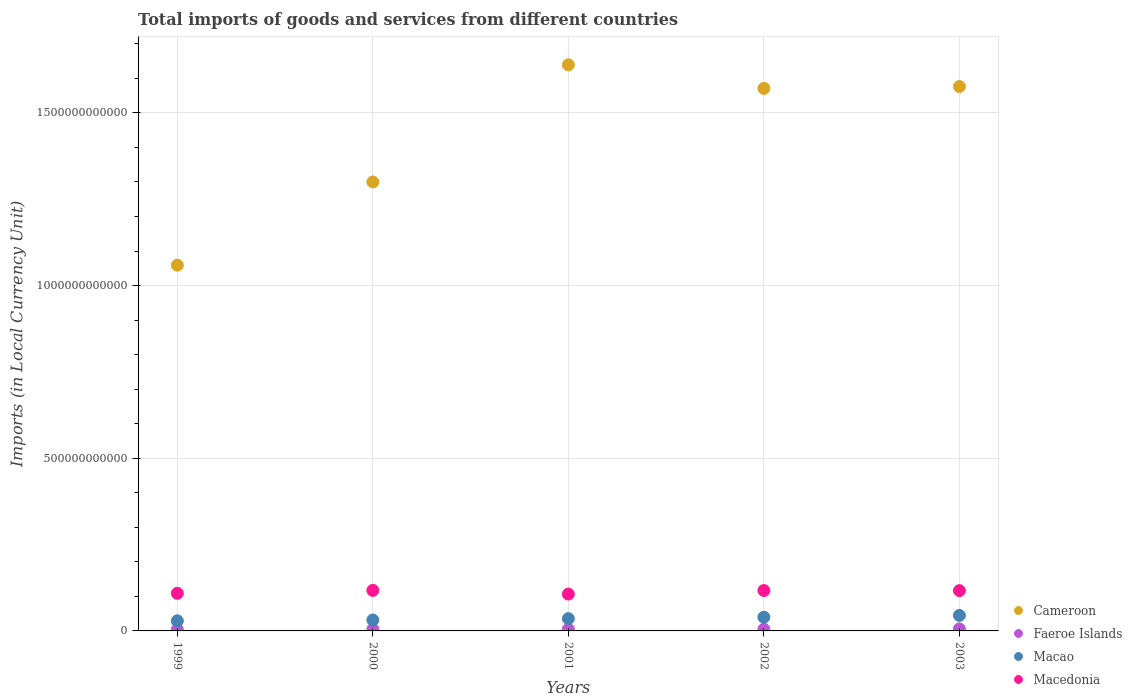How many different coloured dotlines are there?
Your answer should be very brief. 4. Is the number of dotlines equal to the number of legend labels?
Give a very brief answer. Yes. What is the Amount of goods and services imports in Macedonia in 2000?
Your answer should be very brief. 1.17e+11. Across all years, what is the maximum Amount of goods and services imports in Faeroe Islands?
Keep it short and to the point. 5.73e+09. Across all years, what is the minimum Amount of goods and services imports in Faeroe Islands?
Offer a very short reply. 3.90e+09. In which year was the Amount of goods and services imports in Faeroe Islands minimum?
Keep it short and to the point. 1999. What is the total Amount of goods and services imports in Macao in the graph?
Offer a terse response. 1.81e+11. What is the difference between the Amount of goods and services imports in Macao in 2000 and that in 2003?
Your response must be concise. -1.33e+1. What is the difference between the Amount of goods and services imports in Macedonia in 2003 and the Amount of goods and services imports in Macao in 2000?
Give a very brief answer. 8.50e+1. What is the average Amount of goods and services imports in Faeroe Islands per year?
Your response must be concise. 4.85e+09. In the year 2003, what is the difference between the Amount of goods and services imports in Macao and Amount of goods and services imports in Cameroon?
Offer a terse response. -1.53e+12. In how many years, is the Amount of goods and services imports in Cameroon greater than 1300000000000 LCU?
Ensure brevity in your answer.  4. What is the ratio of the Amount of goods and services imports in Faeroe Islands in 1999 to that in 2003?
Your answer should be compact. 0.68. What is the difference between the highest and the second highest Amount of goods and services imports in Macao?
Your response must be concise. 5.34e+09. What is the difference between the highest and the lowest Amount of goods and services imports in Cameroon?
Keep it short and to the point. 5.80e+11. In how many years, is the Amount of goods and services imports in Faeroe Islands greater than the average Amount of goods and services imports in Faeroe Islands taken over all years?
Your answer should be compact. 3. Is the Amount of goods and services imports in Cameroon strictly greater than the Amount of goods and services imports in Faeroe Islands over the years?
Ensure brevity in your answer.  Yes. Is the Amount of goods and services imports in Cameroon strictly less than the Amount of goods and services imports in Macao over the years?
Give a very brief answer. No. What is the difference between two consecutive major ticks on the Y-axis?
Ensure brevity in your answer.  5.00e+11. Are the values on the major ticks of Y-axis written in scientific E-notation?
Provide a succinct answer. No. Does the graph contain any zero values?
Give a very brief answer. No. What is the title of the graph?
Your answer should be very brief. Total imports of goods and services from different countries. Does "Tuvalu" appear as one of the legend labels in the graph?
Offer a terse response. No. What is the label or title of the X-axis?
Make the answer very short. Years. What is the label or title of the Y-axis?
Make the answer very short. Imports (in Local Currency Unit). What is the Imports (in Local Currency Unit) in Cameroon in 1999?
Keep it short and to the point. 1.06e+12. What is the Imports (in Local Currency Unit) of Faeroe Islands in 1999?
Provide a succinct answer. 3.90e+09. What is the Imports (in Local Currency Unit) of Macao in 1999?
Ensure brevity in your answer.  2.92e+1. What is the Imports (in Local Currency Unit) of Macedonia in 1999?
Offer a terse response. 1.09e+11. What is the Imports (in Local Currency Unit) in Cameroon in 2000?
Give a very brief answer. 1.30e+12. What is the Imports (in Local Currency Unit) of Faeroe Islands in 2000?
Ensure brevity in your answer.  4.94e+09. What is the Imports (in Local Currency Unit) in Macao in 2000?
Your answer should be very brief. 3.17e+1. What is the Imports (in Local Currency Unit) of Macedonia in 2000?
Provide a succinct answer. 1.17e+11. What is the Imports (in Local Currency Unit) in Cameroon in 2001?
Your answer should be compact. 1.64e+12. What is the Imports (in Local Currency Unit) of Faeroe Islands in 2001?
Provide a succinct answer. 4.86e+09. What is the Imports (in Local Currency Unit) in Macao in 2001?
Provide a succinct answer. 3.56e+1. What is the Imports (in Local Currency Unit) in Macedonia in 2001?
Ensure brevity in your answer.  1.07e+11. What is the Imports (in Local Currency Unit) of Cameroon in 2002?
Offer a very short reply. 1.57e+12. What is the Imports (in Local Currency Unit) in Faeroe Islands in 2002?
Your answer should be very brief. 4.82e+09. What is the Imports (in Local Currency Unit) of Macao in 2002?
Give a very brief answer. 3.96e+1. What is the Imports (in Local Currency Unit) of Macedonia in 2002?
Your answer should be very brief. 1.17e+11. What is the Imports (in Local Currency Unit) in Cameroon in 2003?
Your response must be concise. 1.58e+12. What is the Imports (in Local Currency Unit) in Faeroe Islands in 2003?
Offer a very short reply. 5.73e+09. What is the Imports (in Local Currency Unit) in Macao in 2003?
Provide a succinct answer. 4.49e+1. What is the Imports (in Local Currency Unit) in Macedonia in 2003?
Your answer should be compact. 1.17e+11. Across all years, what is the maximum Imports (in Local Currency Unit) in Cameroon?
Your answer should be very brief. 1.64e+12. Across all years, what is the maximum Imports (in Local Currency Unit) in Faeroe Islands?
Ensure brevity in your answer.  5.73e+09. Across all years, what is the maximum Imports (in Local Currency Unit) in Macao?
Ensure brevity in your answer.  4.49e+1. Across all years, what is the maximum Imports (in Local Currency Unit) of Macedonia?
Keep it short and to the point. 1.17e+11. Across all years, what is the minimum Imports (in Local Currency Unit) in Cameroon?
Provide a short and direct response. 1.06e+12. Across all years, what is the minimum Imports (in Local Currency Unit) in Faeroe Islands?
Your answer should be very brief. 3.90e+09. Across all years, what is the minimum Imports (in Local Currency Unit) in Macao?
Offer a very short reply. 2.92e+1. Across all years, what is the minimum Imports (in Local Currency Unit) of Macedonia?
Give a very brief answer. 1.07e+11. What is the total Imports (in Local Currency Unit) in Cameroon in the graph?
Your answer should be compact. 7.15e+12. What is the total Imports (in Local Currency Unit) of Faeroe Islands in the graph?
Your answer should be compact. 2.43e+1. What is the total Imports (in Local Currency Unit) of Macao in the graph?
Keep it short and to the point. 1.81e+11. What is the total Imports (in Local Currency Unit) of Macedonia in the graph?
Keep it short and to the point. 5.67e+11. What is the difference between the Imports (in Local Currency Unit) of Cameroon in 1999 and that in 2000?
Your answer should be very brief. -2.41e+11. What is the difference between the Imports (in Local Currency Unit) in Faeroe Islands in 1999 and that in 2000?
Provide a succinct answer. -1.04e+09. What is the difference between the Imports (in Local Currency Unit) in Macao in 1999 and that in 2000?
Your answer should be very brief. -2.44e+09. What is the difference between the Imports (in Local Currency Unit) of Macedonia in 1999 and that in 2000?
Your response must be concise. -8.39e+09. What is the difference between the Imports (in Local Currency Unit) in Cameroon in 1999 and that in 2001?
Give a very brief answer. -5.80e+11. What is the difference between the Imports (in Local Currency Unit) of Faeroe Islands in 1999 and that in 2001?
Provide a succinct answer. -9.61e+08. What is the difference between the Imports (in Local Currency Unit) of Macao in 1999 and that in 2001?
Offer a terse response. -6.38e+09. What is the difference between the Imports (in Local Currency Unit) in Macedonia in 1999 and that in 2001?
Ensure brevity in your answer.  2.30e+09. What is the difference between the Imports (in Local Currency Unit) of Cameroon in 1999 and that in 2002?
Ensure brevity in your answer.  -5.12e+11. What is the difference between the Imports (in Local Currency Unit) of Faeroe Islands in 1999 and that in 2002?
Offer a very short reply. -9.17e+08. What is the difference between the Imports (in Local Currency Unit) of Macao in 1999 and that in 2002?
Make the answer very short. -1.04e+1. What is the difference between the Imports (in Local Currency Unit) of Macedonia in 1999 and that in 2002?
Provide a short and direct response. -7.96e+09. What is the difference between the Imports (in Local Currency Unit) of Cameroon in 1999 and that in 2003?
Make the answer very short. -5.17e+11. What is the difference between the Imports (in Local Currency Unit) in Faeroe Islands in 1999 and that in 2003?
Your answer should be compact. -1.82e+09. What is the difference between the Imports (in Local Currency Unit) of Macao in 1999 and that in 2003?
Your response must be concise. -1.57e+1. What is the difference between the Imports (in Local Currency Unit) of Macedonia in 1999 and that in 2003?
Your answer should be very brief. -7.64e+09. What is the difference between the Imports (in Local Currency Unit) of Cameroon in 2000 and that in 2001?
Make the answer very short. -3.39e+11. What is the difference between the Imports (in Local Currency Unit) in Faeroe Islands in 2000 and that in 2001?
Provide a succinct answer. 7.50e+07. What is the difference between the Imports (in Local Currency Unit) in Macao in 2000 and that in 2001?
Your response must be concise. -3.94e+09. What is the difference between the Imports (in Local Currency Unit) in Macedonia in 2000 and that in 2001?
Make the answer very short. 1.07e+1. What is the difference between the Imports (in Local Currency Unit) in Cameroon in 2000 and that in 2002?
Your answer should be compact. -2.71e+11. What is the difference between the Imports (in Local Currency Unit) of Faeroe Islands in 2000 and that in 2002?
Your response must be concise. 1.19e+08. What is the difference between the Imports (in Local Currency Unit) of Macao in 2000 and that in 2002?
Your answer should be very brief. -7.93e+09. What is the difference between the Imports (in Local Currency Unit) of Macedonia in 2000 and that in 2002?
Give a very brief answer. 4.31e+08. What is the difference between the Imports (in Local Currency Unit) of Cameroon in 2000 and that in 2003?
Your answer should be very brief. -2.76e+11. What is the difference between the Imports (in Local Currency Unit) of Faeroe Islands in 2000 and that in 2003?
Your answer should be compact. -7.89e+08. What is the difference between the Imports (in Local Currency Unit) of Macao in 2000 and that in 2003?
Provide a succinct answer. -1.33e+1. What is the difference between the Imports (in Local Currency Unit) of Macedonia in 2000 and that in 2003?
Your response must be concise. 7.46e+08. What is the difference between the Imports (in Local Currency Unit) in Cameroon in 2001 and that in 2002?
Offer a very short reply. 6.83e+1. What is the difference between the Imports (in Local Currency Unit) in Faeroe Islands in 2001 and that in 2002?
Offer a terse response. 4.40e+07. What is the difference between the Imports (in Local Currency Unit) in Macao in 2001 and that in 2002?
Your response must be concise. -3.99e+09. What is the difference between the Imports (in Local Currency Unit) of Macedonia in 2001 and that in 2002?
Offer a terse response. -1.03e+1. What is the difference between the Imports (in Local Currency Unit) in Cameroon in 2001 and that in 2003?
Ensure brevity in your answer.  6.29e+1. What is the difference between the Imports (in Local Currency Unit) of Faeroe Islands in 2001 and that in 2003?
Provide a succinct answer. -8.64e+08. What is the difference between the Imports (in Local Currency Unit) in Macao in 2001 and that in 2003?
Provide a short and direct response. -9.33e+09. What is the difference between the Imports (in Local Currency Unit) of Macedonia in 2001 and that in 2003?
Your answer should be compact. -9.94e+09. What is the difference between the Imports (in Local Currency Unit) in Cameroon in 2002 and that in 2003?
Your response must be concise. -5.41e+09. What is the difference between the Imports (in Local Currency Unit) of Faeroe Islands in 2002 and that in 2003?
Ensure brevity in your answer.  -9.08e+08. What is the difference between the Imports (in Local Currency Unit) in Macao in 2002 and that in 2003?
Ensure brevity in your answer.  -5.34e+09. What is the difference between the Imports (in Local Currency Unit) of Macedonia in 2002 and that in 2003?
Keep it short and to the point. 3.15e+08. What is the difference between the Imports (in Local Currency Unit) of Cameroon in 1999 and the Imports (in Local Currency Unit) of Faeroe Islands in 2000?
Provide a short and direct response. 1.05e+12. What is the difference between the Imports (in Local Currency Unit) in Cameroon in 1999 and the Imports (in Local Currency Unit) in Macao in 2000?
Provide a short and direct response. 1.03e+12. What is the difference between the Imports (in Local Currency Unit) of Cameroon in 1999 and the Imports (in Local Currency Unit) of Macedonia in 2000?
Provide a succinct answer. 9.42e+11. What is the difference between the Imports (in Local Currency Unit) of Faeroe Islands in 1999 and the Imports (in Local Currency Unit) of Macao in 2000?
Provide a short and direct response. -2.77e+1. What is the difference between the Imports (in Local Currency Unit) in Faeroe Islands in 1999 and the Imports (in Local Currency Unit) in Macedonia in 2000?
Give a very brief answer. -1.13e+11. What is the difference between the Imports (in Local Currency Unit) in Macao in 1999 and the Imports (in Local Currency Unit) in Macedonia in 2000?
Offer a terse response. -8.82e+1. What is the difference between the Imports (in Local Currency Unit) in Cameroon in 1999 and the Imports (in Local Currency Unit) in Faeroe Islands in 2001?
Your answer should be very brief. 1.05e+12. What is the difference between the Imports (in Local Currency Unit) in Cameroon in 1999 and the Imports (in Local Currency Unit) in Macao in 2001?
Offer a very short reply. 1.02e+12. What is the difference between the Imports (in Local Currency Unit) of Cameroon in 1999 and the Imports (in Local Currency Unit) of Macedonia in 2001?
Offer a very short reply. 9.52e+11. What is the difference between the Imports (in Local Currency Unit) in Faeroe Islands in 1999 and the Imports (in Local Currency Unit) in Macao in 2001?
Offer a very short reply. -3.17e+1. What is the difference between the Imports (in Local Currency Unit) in Faeroe Islands in 1999 and the Imports (in Local Currency Unit) in Macedonia in 2001?
Your answer should be very brief. -1.03e+11. What is the difference between the Imports (in Local Currency Unit) of Macao in 1999 and the Imports (in Local Currency Unit) of Macedonia in 2001?
Your answer should be compact. -7.75e+1. What is the difference between the Imports (in Local Currency Unit) in Cameroon in 1999 and the Imports (in Local Currency Unit) in Faeroe Islands in 2002?
Keep it short and to the point. 1.05e+12. What is the difference between the Imports (in Local Currency Unit) in Cameroon in 1999 and the Imports (in Local Currency Unit) in Macao in 2002?
Your answer should be very brief. 1.02e+12. What is the difference between the Imports (in Local Currency Unit) of Cameroon in 1999 and the Imports (in Local Currency Unit) of Macedonia in 2002?
Your answer should be compact. 9.42e+11. What is the difference between the Imports (in Local Currency Unit) of Faeroe Islands in 1999 and the Imports (in Local Currency Unit) of Macao in 2002?
Your response must be concise. -3.57e+1. What is the difference between the Imports (in Local Currency Unit) in Faeroe Islands in 1999 and the Imports (in Local Currency Unit) in Macedonia in 2002?
Give a very brief answer. -1.13e+11. What is the difference between the Imports (in Local Currency Unit) of Macao in 1999 and the Imports (in Local Currency Unit) of Macedonia in 2002?
Provide a short and direct response. -8.78e+1. What is the difference between the Imports (in Local Currency Unit) in Cameroon in 1999 and the Imports (in Local Currency Unit) in Faeroe Islands in 2003?
Make the answer very short. 1.05e+12. What is the difference between the Imports (in Local Currency Unit) in Cameroon in 1999 and the Imports (in Local Currency Unit) in Macao in 2003?
Provide a short and direct response. 1.01e+12. What is the difference between the Imports (in Local Currency Unit) of Cameroon in 1999 and the Imports (in Local Currency Unit) of Macedonia in 2003?
Give a very brief answer. 9.42e+11. What is the difference between the Imports (in Local Currency Unit) of Faeroe Islands in 1999 and the Imports (in Local Currency Unit) of Macao in 2003?
Offer a terse response. -4.10e+1. What is the difference between the Imports (in Local Currency Unit) in Faeroe Islands in 1999 and the Imports (in Local Currency Unit) in Macedonia in 2003?
Your answer should be compact. -1.13e+11. What is the difference between the Imports (in Local Currency Unit) in Macao in 1999 and the Imports (in Local Currency Unit) in Macedonia in 2003?
Keep it short and to the point. -8.74e+1. What is the difference between the Imports (in Local Currency Unit) in Cameroon in 2000 and the Imports (in Local Currency Unit) in Faeroe Islands in 2001?
Give a very brief answer. 1.30e+12. What is the difference between the Imports (in Local Currency Unit) in Cameroon in 2000 and the Imports (in Local Currency Unit) in Macao in 2001?
Your answer should be very brief. 1.26e+12. What is the difference between the Imports (in Local Currency Unit) of Cameroon in 2000 and the Imports (in Local Currency Unit) of Macedonia in 2001?
Ensure brevity in your answer.  1.19e+12. What is the difference between the Imports (in Local Currency Unit) in Faeroe Islands in 2000 and the Imports (in Local Currency Unit) in Macao in 2001?
Provide a succinct answer. -3.07e+1. What is the difference between the Imports (in Local Currency Unit) of Faeroe Islands in 2000 and the Imports (in Local Currency Unit) of Macedonia in 2001?
Provide a short and direct response. -1.02e+11. What is the difference between the Imports (in Local Currency Unit) of Macao in 2000 and the Imports (in Local Currency Unit) of Macedonia in 2001?
Provide a short and direct response. -7.51e+1. What is the difference between the Imports (in Local Currency Unit) in Cameroon in 2000 and the Imports (in Local Currency Unit) in Faeroe Islands in 2002?
Provide a short and direct response. 1.30e+12. What is the difference between the Imports (in Local Currency Unit) of Cameroon in 2000 and the Imports (in Local Currency Unit) of Macao in 2002?
Offer a terse response. 1.26e+12. What is the difference between the Imports (in Local Currency Unit) of Cameroon in 2000 and the Imports (in Local Currency Unit) of Macedonia in 2002?
Your response must be concise. 1.18e+12. What is the difference between the Imports (in Local Currency Unit) of Faeroe Islands in 2000 and the Imports (in Local Currency Unit) of Macao in 2002?
Make the answer very short. -3.46e+1. What is the difference between the Imports (in Local Currency Unit) in Faeroe Islands in 2000 and the Imports (in Local Currency Unit) in Macedonia in 2002?
Provide a short and direct response. -1.12e+11. What is the difference between the Imports (in Local Currency Unit) in Macao in 2000 and the Imports (in Local Currency Unit) in Macedonia in 2002?
Offer a terse response. -8.53e+1. What is the difference between the Imports (in Local Currency Unit) of Cameroon in 2000 and the Imports (in Local Currency Unit) of Faeroe Islands in 2003?
Keep it short and to the point. 1.29e+12. What is the difference between the Imports (in Local Currency Unit) of Cameroon in 2000 and the Imports (in Local Currency Unit) of Macao in 2003?
Provide a short and direct response. 1.26e+12. What is the difference between the Imports (in Local Currency Unit) in Cameroon in 2000 and the Imports (in Local Currency Unit) in Macedonia in 2003?
Make the answer very short. 1.18e+12. What is the difference between the Imports (in Local Currency Unit) in Faeroe Islands in 2000 and the Imports (in Local Currency Unit) in Macao in 2003?
Make the answer very short. -4.00e+1. What is the difference between the Imports (in Local Currency Unit) in Faeroe Islands in 2000 and the Imports (in Local Currency Unit) in Macedonia in 2003?
Provide a succinct answer. -1.12e+11. What is the difference between the Imports (in Local Currency Unit) in Macao in 2000 and the Imports (in Local Currency Unit) in Macedonia in 2003?
Make the answer very short. -8.50e+1. What is the difference between the Imports (in Local Currency Unit) in Cameroon in 2001 and the Imports (in Local Currency Unit) in Faeroe Islands in 2002?
Your answer should be very brief. 1.63e+12. What is the difference between the Imports (in Local Currency Unit) in Cameroon in 2001 and the Imports (in Local Currency Unit) in Macao in 2002?
Your answer should be very brief. 1.60e+12. What is the difference between the Imports (in Local Currency Unit) in Cameroon in 2001 and the Imports (in Local Currency Unit) in Macedonia in 2002?
Your answer should be very brief. 1.52e+12. What is the difference between the Imports (in Local Currency Unit) in Faeroe Islands in 2001 and the Imports (in Local Currency Unit) in Macao in 2002?
Your answer should be very brief. -3.47e+1. What is the difference between the Imports (in Local Currency Unit) of Faeroe Islands in 2001 and the Imports (in Local Currency Unit) of Macedonia in 2002?
Provide a succinct answer. -1.12e+11. What is the difference between the Imports (in Local Currency Unit) in Macao in 2001 and the Imports (in Local Currency Unit) in Macedonia in 2002?
Provide a short and direct response. -8.14e+1. What is the difference between the Imports (in Local Currency Unit) in Cameroon in 2001 and the Imports (in Local Currency Unit) in Faeroe Islands in 2003?
Ensure brevity in your answer.  1.63e+12. What is the difference between the Imports (in Local Currency Unit) of Cameroon in 2001 and the Imports (in Local Currency Unit) of Macao in 2003?
Provide a succinct answer. 1.59e+12. What is the difference between the Imports (in Local Currency Unit) in Cameroon in 2001 and the Imports (in Local Currency Unit) in Macedonia in 2003?
Make the answer very short. 1.52e+12. What is the difference between the Imports (in Local Currency Unit) of Faeroe Islands in 2001 and the Imports (in Local Currency Unit) of Macao in 2003?
Offer a terse response. -4.01e+1. What is the difference between the Imports (in Local Currency Unit) in Faeroe Islands in 2001 and the Imports (in Local Currency Unit) in Macedonia in 2003?
Offer a very short reply. -1.12e+11. What is the difference between the Imports (in Local Currency Unit) of Macao in 2001 and the Imports (in Local Currency Unit) of Macedonia in 2003?
Give a very brief answer. -8.11e+1. What is the difference between the Imports (in Local Currency Unit) in Cameroon in 2002 and the Imports (in Local Currency Unit) in Faeroe Islands in 2003?
Offer a terse response. 1.57e+12. What is the difference between the Imports (in Local Currency Unit) of Cameroon in 2002 and the Imports (in Local Currency Unit) of Macao in 2003?
Your response must be concise. 1.53e+12. What is the difference between the Imports (in Local Currency Unit) in Cameroon in 2002 and the Imports (in Local Currency Unit) in Macedonia in 2003?
Ensure brevity in your answer.  1.45e+12. What is the difference between the Imports (in Local Currency Unit) in Faeroe Islands in 2002 and the Imports (in Local Currency Unit) in Macao in 2003?
Keep it short and to the point. -4.01e+1. What is the difference between the Imports (in Local Currency Unit) of Faeroe Islands in 2002 and the Imports (in Local Currency Unit) of Macedonia in 2003?
Provide a succinct answer. -1.12e+11. What is the difference between the Imports (in Local Currency Unit) of Macao in 2002 and the Imports (in Local Currency Unit) of Macedonia in 2003?
Your answer should be compact. -7.71e+1. What is the average Imports (in Local Currency Unit) in Cameroon per year?
Your answer should be very brief. 1.43e+12. What is the average Imports (in Local Currency Unit) in Faeroe Islands per year?
Offer a very short reply. 4.85e+09. What is the average Imports (in Local Currency Unit) of Macao per year?
Your answer should be very brief. 3.62e+1. What is the average Imports (in Local Currency Unit) of Macedonia per year?
Keep it short and to the point. 1.13e+11. In the year 1999, what is the difference between the Imports (in Local Currency Unit) in Cameroon and Imports (in Local Currency Unit) in Faeroe Islands?
Give a very brief answer. 1.06e+12. In the year 1999, what is the difference between the Imports (in Local Currency Unit) in Cameroon and Imports (in Local Currency Unit) in Macao?
Your answer should be very brief. 1.03e+12. In the year 1999, what is the difference between the Imports (in Local Currency Unit) in Cameroon and Imports (in Local Currency Unit) in Macedonia?
Provide a short and direct response. 9.50e+11. In the year 1999, what is the difference between the Imports (in Local Currency Unit) in Faeroe Islands and Imports (in Local Currency Unit) in Macao?
Your answer should be very brief. -2.53e+1. In the year 1999, what is the difference between the Imports (in Local Currency Unit) of Faeroe Islands and Imports (in Local Currency Unit) of Macedonia?
Your answer should be compact. -1.05e+11. In the year 1999, what is the difference between the Imports (in Local Currency Unit) of Macao and Imports (in Local Currency Unit) of Macedonia?
Make the answer very short. -7.98e+1. In the year 2000, what is the difference between the Imports (in Local Currency Unit) in Cameroon and Imports (in Local Currency Unit) in Faeroe Islands?
Offer a terse response. 1.30e+12. In the year 2000, what is the difference between the Imports (in Local Currency Unit) in Cameroon and Imports (in Local Currency Unit) in Macao?
Make the answer very short. 1.27e+12. In the year 2000, what is the difference between the Imports (in Local Currency Unit) in Cameroon and Imports (in Local Currency Unit) in Macedonia?
Make the answer very short. 1.18e+12. In the year 2000, what is the difference between the Imports (in Local Currency Unit) of Faeroe Islands and Imports (in Local Currency Unit) of Macao?
Offer a terse response. -2.67e+1. In the year 2000, what is the difference between the Imports (in Local Currency Unit) in Faeroe Islands and Imports (in Local Currency Unit) in Macedonia?
Your response must be concise. -1.12e+11. In the year 2000, what is the difference between the Imports (in Local Currency Unit) of Macao and Imports (in Local Currency Unit) of Macedonia?
Your response must be concise. -8.57e+1. In the year 2001, what is the difference between the Imports (in Local Currency Unit) of Cameroon and Imports (in Local Currency Unit) of Faeroe Islands?
Ensure brevity in your answer.  1.63e+12. In the year 2001, what is the difference between the Imports (in Local Currency Unit) of Cameroon and Imports (in Local Currency Unit) of Macao?
Ensure brevity in your answer.  1.60e+12. In the year 2001, what is the difference between the Imports (in Local Currency Unit) in Cameroon and Imports (in Local Currency Unit) in Macedonia?
Offer a terse response. 1.53e+12. In the year 2001, what is the difference between the Imports (in Local Currency Unit) in Faeroe Islands and Imports (in Local Currency Unit) in Macao?
Keep it short and to the point. -3.07e+1. In the year 2001, what is the difference between the Imports (in Local Currency Unit) in Faeroe Islands and Imports (in Local Currency Unit) in Macedonia?
Offer a very short reply. -1.02e+11. In the year 2001, what is the difference between the Imports (in Local Currency Unit) in Macao and Imports (in Local Currency Unit) in Macedonia?
Your answer should be compact. -7.11e+1. In the year 2002, what is the difference between the Imports (in Local Currency Unit) in Cameroon and Imports (in Local Currency Unit) in Faeroe Islands?
Provide a short and direct response. 1.57e+12. In the year 2002, what is the difference between the Imports (in Local Currency Unit) of Cameroon and Imports (in Local Currency Unit) of Macao?
Keep it short and to the point. 1.53e+12. In the year 2002, what is the difference between the Imports (in Local Currency Unit) in Cameroon and Imports (in Local Currency Unit) in Macedonia?
Your response must be concise. 1.45e+12. In the year 2002, what is the difference between the Imports (in Local Currency Unit) in Faeroe Islands and Imports (in Local Currency Unit) in Macao?
Keep it short and to the point. -3.48e+1. In the year 2002, what is the difference between the Imports (in Local Currency Unit) of Faeroe Islands and Imports (in Local Currency Unit) of Macedonia?
Provide a succinct answer. -1.12e+11. In the year 2002, what is the difference between the Imports (in Local Currency Unit) in Macao and Imports (in Local Currency Unit) in Macedonia?
Give a very brief answer. -7.74e+1. In the year 2003, what is the difference between the Imports (in Local Currency Unit) in Cameroon and Imports (in Local Currency Unit) in Faeroe Islands?
Your answer should be compact. 1.57e+12. In the year 2003, what is the difference between the Imports (in Local Currency Unit) of Cameroon and Imports (in Local Currency Unit) of Macao?
Your answer should be compact. 1.53e+12. In the year 2003, what is the difference between the Imports (in Local Currency Unit) of Cameroon and Imports (in Local Currency Unit) of Macedonia?
Your response must be concise. 1.46e+12. In the year 2003, what is the difference between the Imports (in Local Currency Unit) of Faeroe Islands and Imports (in Local Currency Unit) of Macao?
Provide a succinct answer. -3.92e+1. In the year 2003, what is the difference between the Imports (in Local Currency Unit) in Faeroe Islands and Imports (in Local Currency Unit) in Macedonia?
Make the answer very short. -1.11e+11. In the year 2003, what is the difference between the Imports (in Local Currency Unit) in Macao and Imports (in Local Currency Unit) in Macedonia?
Make the answer very short. -7.17e+1. What is the ratio of the Imports (in Local Currency Unit) in Cameroon in 1999 to that in 2000?
Keep it short and to the point. 0.81. What is the ratio of the Imports (in Local Currency Unit) of Faeroe Islands in 1999 to that in 2000?
Provide a short and direct response. 0.79. What is the ratio of the Imports (in Local Currency Unit) in Macao in 1999 to that in 2000?
Give a very brief answer. 0.92. What is the ratio of the Imports (in Local Currency Unit) in Macedonia in 1999 to that in 2000?
Provide a succinct answer. 0.93. What is the ratio of the Imports (in Local Currency Unit) in Cameroon in 1999 to that in 2001?
Ensure brevity in your answer.  0.65. What is the ratio of the Imports (in Local Currency Unit) of Faeroe Islands in 1999 to that in 2001?
Ensure brevity in your answer.  0.8. What is the ratio of the Imports (in Local Currency Unit) of Macao in 1999 to that in 2001?
Your answer should be compact. 0.82. What is the ratio of the Imports (in Local Currency Unit) of Macedonia in 1999 to that in 2001?
Keep it short and to the point. 1.02. What is the ratio of the Imports (in Local Currency Unit) in Cameroon in 1999 to that in 2002?
Give a very brief answer. 0.67. What is the ratio of the Imports (in Local Currency Unit) of Faeroe Islands in 1999 to that in 2002?
Your response must be concise. 0.81. What is the ratio of the Imports (in Local Currency Unit) in Macao in 1999 to that in 2002?
Provide a short and direct response. 0.74. What is the ratio of the Imports (in Local Currency Unit) of Macedonia in 1999 to that in 2002?
Your answer should be compact. 0.93. What is the ratio of the Imports (in Local Currency Unit) of Cameroon in 1999 to that in 2003?
Make the answer very short. 0.67. What is the ratio of the Imports (in Local Currency Unit) of Faeroe Islands in 1999 to that in 2003?
Your answer should be very brief. 0.68. What is the ratio of the Imports (in Local Currency Unit) of Macao in 1999 to that in 2003?
Offer a very short reply. 0.65. What is the ratio of the Imports (in Local Currency Unit) in Macedonia in 1999 to that in 2003?
Provide a short and direct response. 0.93. What is the ratio of the Imports (in Local Currency Unit) in Cameroon in 2000 to that in 2001?
Offer a very short reply. 0.79. What is the ratio of the Imports (in Local Currency Unit) in Faeroe Islands in 2000 to that in 2001?
Your answer should be compact. 1.02. What is the ratio of the Imports (in Local Currency Unit) in Macao in 2000 to that in 2001?
Give a very brief answer. 0.89. What is the ratio of the Imports (in Local Currency Unit) in Macedonia in 2000 to that in 2001?
Give a very brief answer. 1.1. What is the ratio of the Imports (in Local Currency Unit) in Cameroon in 2000 to that in 2002?
Provide a succinct answer. 0.83. What is the ratio of the Imports (in Local Currency Unit) in Faeroe Islands in 2000 to that in 2002?
Offer a very short reply. 1.02. What is the ratio of the Imports (in Local Currency Unit) in Macao in 2000 to that in 2002?
Provide a short and direct response. 0.8. What is the ratio of the Imports (in Local Currency Unit) of Cameroon in 2000 to that in 2003?
Your response must be concise. 0.82. What is the ratio of the Imports (in Local Currency Unit) of Faeroe Islands in 2000 to that in 2003?
Provide a succinct answer. 0.86. What is the ratio of the Imports (in Local Currency Unit) in Macao in 2000 to that in 2003?
Provide a short and direct response. 0.7. What is the ratio of the Imports (in Local Currency Unit) in Macedonia in 2000 to that in 2003?
Make the answer very short. 1.01. What is the ratio of the Imports (in Local Currency Unit) in Cameroon in 2001 to that in 2002?
Your response must be concise. 1.04. What is the ratio of the Imports (in Local Currency Unit) of Faeroe Islands in 2001 to that in 2002?
Make the answer very short. 1.01. What is the ratio of the Imports (in Local Currency Unit) of Macao in 2001 to that in 2002?
Your answer should be compact. 0.9. What is the ratio of the Imports (in Local Currency Unit) in Macedonia in 2001 to that in 2002?
Give a very brief answer. 0.91. What is the ratio of the Imports (in Local Currency Unit) of Cameroon in 2001 to that in 2003?
Give a very brief answer. 1.04. What is the ratio of the Imports (in Local Currency Unit) of Faeroe Islands in 2001 to that in 2003?
Your answer should be compact. 0.85. What is the ratio of the Imports (in Local Currency Unit) in Macao in 2001 to that in 2003?
Keep it short and to the point. 0.79. What is the ratio of the Imports (in Local Currency Unit) in Macedonia in 2001 to that in 2003?
Provide a succinct answer. 0.91. What is the ratio of the Imports (in Local Currency Unit) of Cameroon in 2002 to that in 2003?
Offer a terse response. 1. What is the ratio of the Imports (in Local Currency Unit) in Faeroe Islands in 2002 to that in 2003?
Keep it short and to the point. 0.84. What is the ratio of the Imports (in Local Currency Unit) in Macao in 2002 to that in 2003?
Provide a short and direct response. 0.88. What is the ratio of the Imports (in Local Currency Unit) of Macedonia in 2002 to that in 2003?
Make the answer very short. 1. What is the difference between the highest and the second highest Imports (in Local Currency Unit) of Cameroon?
Provide a short and direct response. 6.29e+1. What is the difference between the highest and the second highest Imports (in Local Currency Unit) of Faeroe Islands?
Ensure brevity in your answer.  7.89e+08. What is the difference between the highest and the second highest Imports (in Local Currency Unit) in Macao?
Your answer should be compact. 5.34e+09. What is the difference between the highest and the second highest Imports (in Local Currency Unit) in Macedonia?
Keep it short and to the point. 4.31e+08. What is the difference between the highest and the lowest Imports (in Local Currency Unit) in Cameroon?
Provide a short and direct response. 5.80e+11. What is the difference between the highest and the lowest Imports (in Local Currency Unit) in Faeroe Islands?
Your answer should be very brief. 1.82e+09. What is the difference between the highest and the lowest Imports (in Local Currency Unit) of Macao?
Your answer should be very brief. 1.57e+1. What is the difference between the highest and the lowest Imports (in Local Currency Unit) of Macedonia?
Offer a terse response. 1.07e+1. 